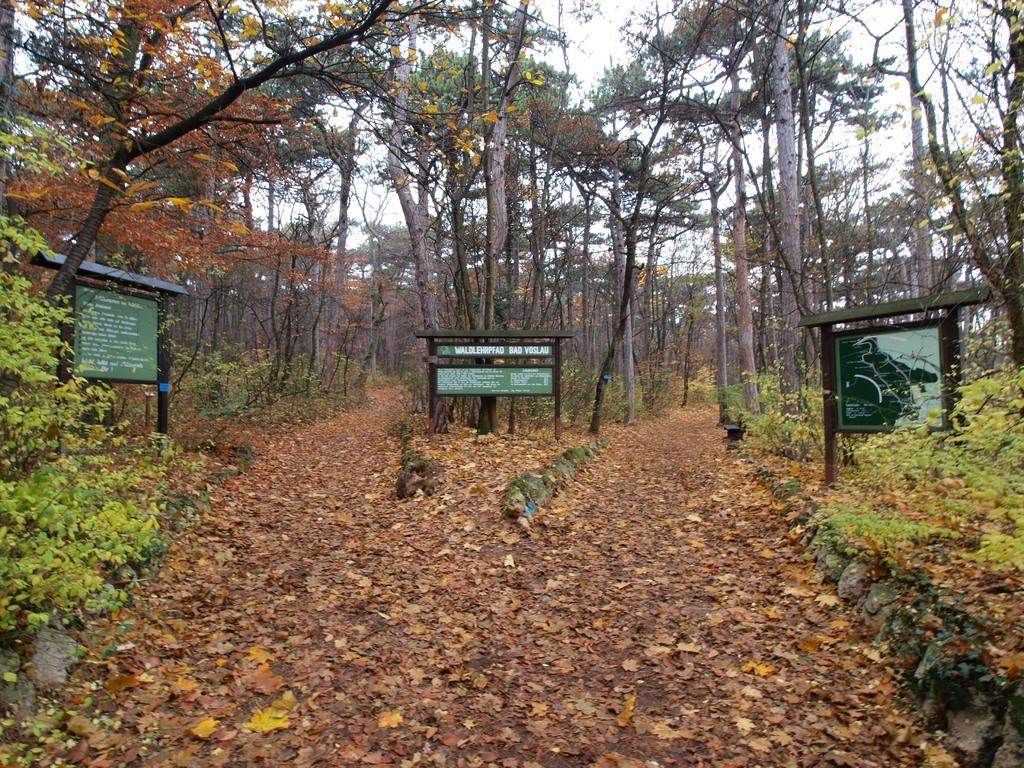Please provide a concise description of this image. In this image I can see few green colour boards in the centre and on it I can see something is written. I can also see number of trees and I can also see leaves on the ground. 